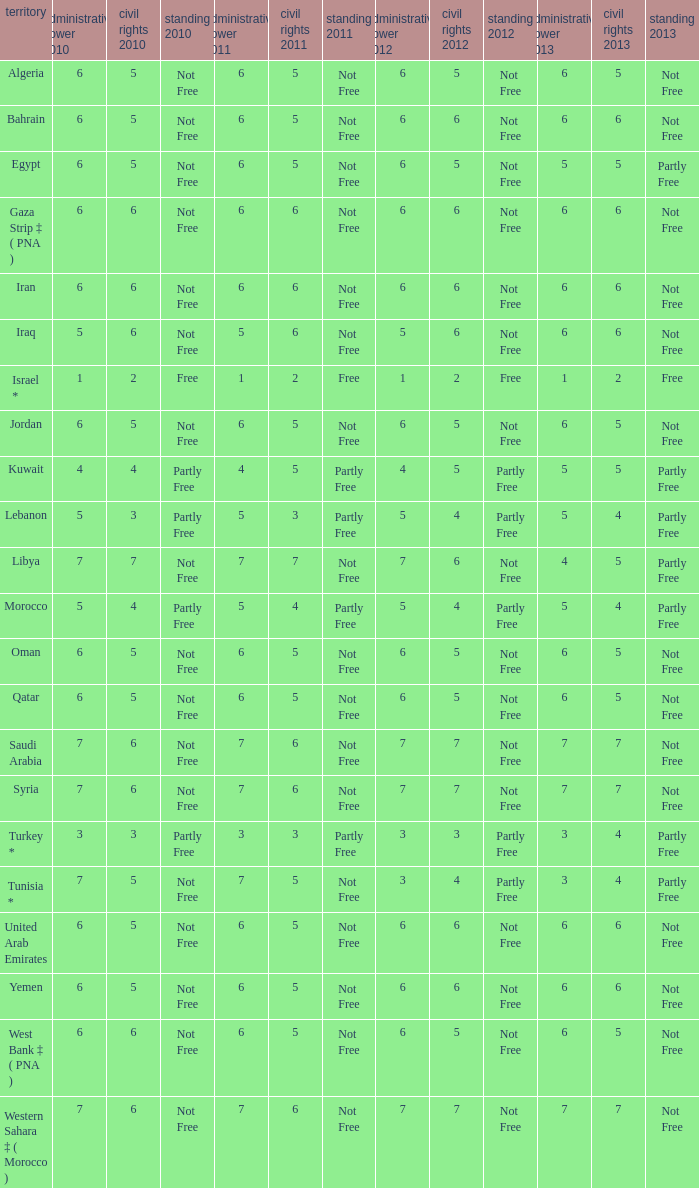How many civil liberties 2013 values are associated with a 2010 political rights value of 6, civil liberties 2012 values over 5, and political rights 2011 under 6? 0.0. 